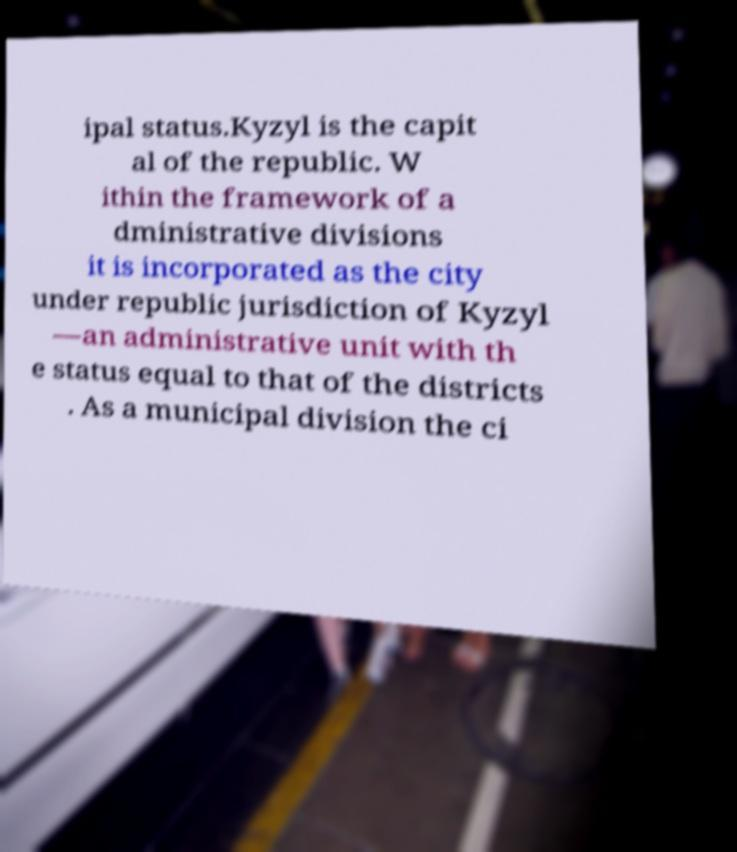Please identify and transcribe the text found in this image. ipal status.Kyzyl is the capit al of the republic. W ithin the framework of a dministrative divisions it is incorporated as the city under republic jurisdiction of Kyzyl —an administrative unit with th e status equal to that of the districts . As a municipal division the ci 